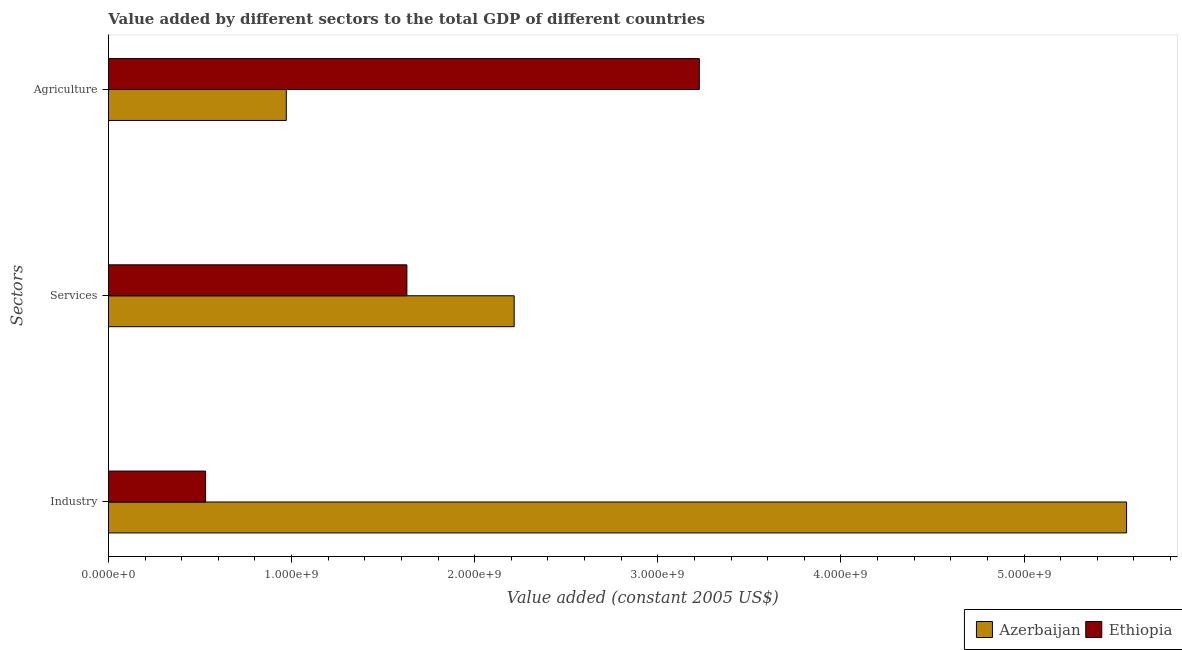How many different coloured bars are there?
Ensure brevity in your answer.  2. How many groups of bars are there?
Your answer should be compact. 3. Are the number of bars on each tick of the Y-axis equal?
Provide a short and direct response. Yes. How many bars are there on the 2nd tick from the bottom?
Make the answer very short. 2. What is the label of the 2nd group of bars from the top?
Offer a terse response. Services. What is the value added by services in Ethiopia?
Provide a short and direct response. 1.63e+09. Across all countries, what is the maximum value added by services?
Keep it short and to the point. 2.22e+09. Across all countries, what is the minimum value added by agricultural sector?
Keep it short and to the point. 9.71e+08. In which country was the value added by services maximum?
Provide a short and direct response. Azerbaijan. In which country was the value added by services minimum?
Make the answer very short. Ethiopia. What is the total value added by services in the graph?
Your answer should be very brief. 3.85e+09. What is the difference between the value added by services in Ethiopia and that in Azerbaijan?
Provide a short and direct response. -5.86e+08. What is the difference between the value added by agricultural sector in Ethiopia and the value added by industrial sector in Azerbaijan?
Offer a very short reply. -2.33e+09. What is the average value added by industrial sector per country?
Your answer should be very brief. 3.05e+09. What is the difference between the value added by agricultural sector and value added by services in Azerbaijan?
Make the answer very short. -1.24e+09. In how many countries, is the value added by agricultural sector greater than 2000000000 US$?
Offer a very short reply. 1. What is the ratio of the value added by services in Ethiopia to that in Azerbaijan?
Ensure brevity in your answer.  0.74. Is the value added by agricultural sector in Azerbaijan less than that in Ethiopia?
Offer a terse response. Yes. What is the difference between the highest and the second highest value added by industrial sector?
Offer a very short reply. 5.03e+09. What is the difference between the highest and the lowest value added by agricultural sector?
Your answer should be compact. 2.26e+09. In how many countries, is the value added by industrial sector greater than the average value added by industrial sector taken over all countries?
Offer a terse response. 1. Is the sum of the value added by industrial sector in Azerbaijan and Ethiopia greater than the maximum value added by services across all countries?
Ensure brevity in your answer.  Yes. What does the 2nd bar from the top in Services represents?
Your answer should be compact. Azerbaijan. What does the 1st bar from the bottom in Services represents?
Make the answer very short. Azerbaijan. Is it the case that in every country, the sum of the value added by industrial sector and value added by services is greater than the value added by agricultural sector?
Ensure brevity in your answer.  No. How many bars are there?
Offer a terse response. 6. How many countries are there in the graph?
Offer a terse response. 2. Does the graph contain any zero values?
Keep it short and to the point. No. Where does the legend appear in the graph?
Provide a succinct answer. Bottom right. How many legend labels are there?
Keep it short and to the point. 2. How are the legend labels stacked?
Offer a terse response. Horizontal. What is the title of the graph?
Your answer should be compact. Value added by different sectors to the total GDP of different countries. Does "Caribbean small states" appear as one of the legend labels in the graph?
Make the answer very short. No. What is the label or title of the X-axis?
Provide a short and direct response. Value added (constant 2005 US$). What is the label or title of the Y-axis?
Your answer should be very brief. Sectors. What is the Value added (constant 2005 US$) of Azerbaijan in Industry?
Your answer should be compact. 5.56e+09. What is the Value added (constant 2005 US$) in Ethiopia in Industry?
Your answer should be very brief. 5.31e+08. What is the Value added (constant 2005 US$) of Azerbaijan in Services?
Your response must be concise. 2.22e+09. What is the Value added (constant 2005 US$) of Ethiopia in Services?
Keep it short and to the point. 1.63e+09. What is the Value added (constant 2005 US$) in Azerbaijan in Agriculture?
Offer a terse response. 9.71e+08. What is the Value added (constant 2005 US$) in Ethiopia in Agriculture?
Ensure brevity in your answer.  3.23e+09. Across all Sectors, what is the maximum Value added (constant 2005 US$) of Azerbaijan?
Give a very brief answer. 5.56e+09. Across all Sectors, what is the maximum Value added (constant 2005 US$) of Ethiopia?
Your answer should be compact. 3.23e+09. Across all Sectors, what is the minimum Value added (constant 2005 US$) in Azerbaijan?
Make the answer very short. 9.71e+08. Across all Sectors, what is the minimum Value added (constant 2005 US$) of Ethiopia?
Keep it short and to the point. 5.31e+08. What is the total Value added (constant 2005 US$) of Azerbaijan in the graph?
Provide a short and direct response. 8.75e+09. What is the total Value added (constant 2005 US$) in Ethiopia in the graph?
Your answer should be very brief. 5.39e+09. What is the difference between the Value added (constant 2005 US$) in Azerbaijan in Industry and that in Services?
Your response must be concise. 3.34e+09. What is the difference between the Value added (constant 2005 US$) in Ethiopia in Industry and that in Services?
Your response must be concise. -1.10e+09. What is the difference between the Value added (constant 2005 US$) in Azerbaijan in Industry and that in Agriculture?
Keep it short and to the point. 4.59e+09. What is the difference between the Value added (constant 2005 US$) in Ethiopia in Industry and that in Agriculture?
Your response must be concise. -2.70e+09. What is the difference between the Value added (constant 2005 US$) in Azerbaijan in Services and that in Agriculture?
Provide a succinct answer. 1.24e+09. What is the difference between the Value added (constant 2005 US$) in Ethiopia in Services and that in Agriculture?
Your response must be concise. -1.60e+09. What is the difference between the Value added (constant 2005 US$) of Azerbaijan in Industry and the Value added (constant 2005 US$) of Ethiopia in Services?
Offer a very short reply. 3.93e+09. What is the difference between the Value added (constant 2005 US$) in Azerbaijan in Industry and the Value added (constant 2005 US$) in Ethiopia in Agriculture?
Keep it short and to the point. 2.33e+09. What is the difference between the Value added (constant 2005 US$) in Azerbaijan in Services and the Value added (constant 2005 US$) in Ethiopia in Agriculture?
Make the answer very short. -1.01e+09. What is the average Value added (constant 2005 US$) of Azerbaijan per Sectors?
Your response must be concise. 2.92e+09. What is the average Value added (constant 2005 US$) in Ethiopia per Sectors?
Your response must be concise. 1.80e+09. What is the difference between the Value added (constant 2005 US$) of Azerbaijan and Value added (constant 2005 US$) of Ethiopia in Industry?
Give a very brief answer. 5.03e+09. What is the difference between the Value added (constant 2005 US$) in Azerbaijan and Value added (constant 2005 US$) in Ethiopia in Services?
Ensure brevity in your answer.  5.86e+08. What is the difference between the Value added (constant 2005 US$) in Azerbaijan and Value added (constant 2005 US$) in Ethiopia in Agriculture?
Offer a very short reply. -2.26e+09. What is the ratio of the Value added (constant 2005 US$) in Azerbaijan in Industry to that in Services?
Keep it short and to the point. 2.51. What is the ratio of the Value added (constant 2005 US$) of Ethiopia in Industry to that in Services?
Keep it short and to the point. 0.33. What is the ratio of the Value added (constant 2005 US$) in Azerbaijan in Industry to that in Agriculture?
Give a very brief answer. 5.72. What is the ratio of the Value added (constant 2005 US$) in Ethiopia in Industry to that in Agriculture?
Provide a short and direct response. 0.16. What is the ratio of the Value added (constant 2005 US$) of Azerbaijan in Services to that in Agriculture?
Your answer should be very brief. 2.28. What is the ratio of the Value added (constant 2005 US$) in Ethiopia in Services to that in Agriculture?
Make the answer very short. 0.51. What is the difference between the highest and the second highest Value added (constant 2005 US$) of Azerbaijan?
Keep it short and to the point. 3.34e+09. What is the difference between the highest and the second highest Value added (constant 2005 US$) in Ethiopia?
Provide a succinct answer. 1.60e+09. What is the difference between the highest and the lowest Value added (constant 2005 US$) in Azerbaijan?
Give a very brief answer. 4.59e+09. What is the difference between the highest and the lowest Value added (constant 2005 US$) of Ethiopia?
Your answer should be very brief. 2.70e+09. 